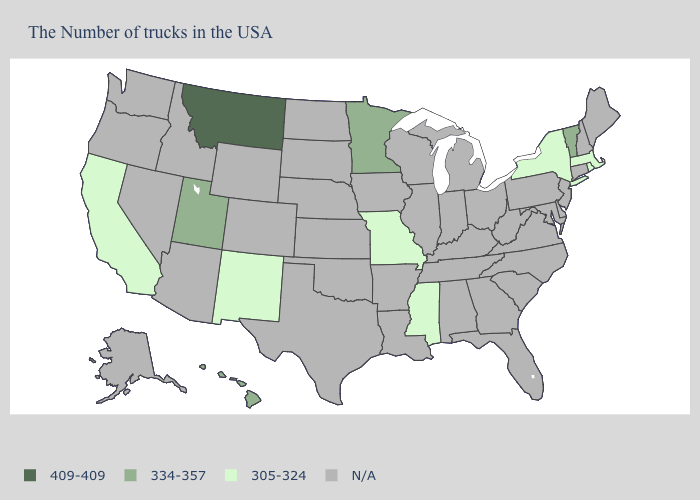What is the value of Alaska?
Short answer required. N/A. Which states hav the highest value in the MidWest?
Keep it brief. Minnesota. What is the value of New Jersey?
Short answer required. N/A. What is the value of Rhode Island?
Short answer required. 305-324. What is the value of Pennsylvania?
Give a very brief answer. N/A. What is the value of Massachusetts?
Answer briefly. 305-324. What is the value of Rhode Island?
Write a very short answer. 305-324. Does the first symbol in the legend represent the smallest category?
Answer briefly. No. Does Vermont have the lowest value in the USA?
Give a very brief answer. No. What is the lowest value in the West?
Be succinct. 305-324. What is the value of Washington?
Quick response, please. N/A. What is the lowest value in the MidWest?
Answer briefly. 305-324. 